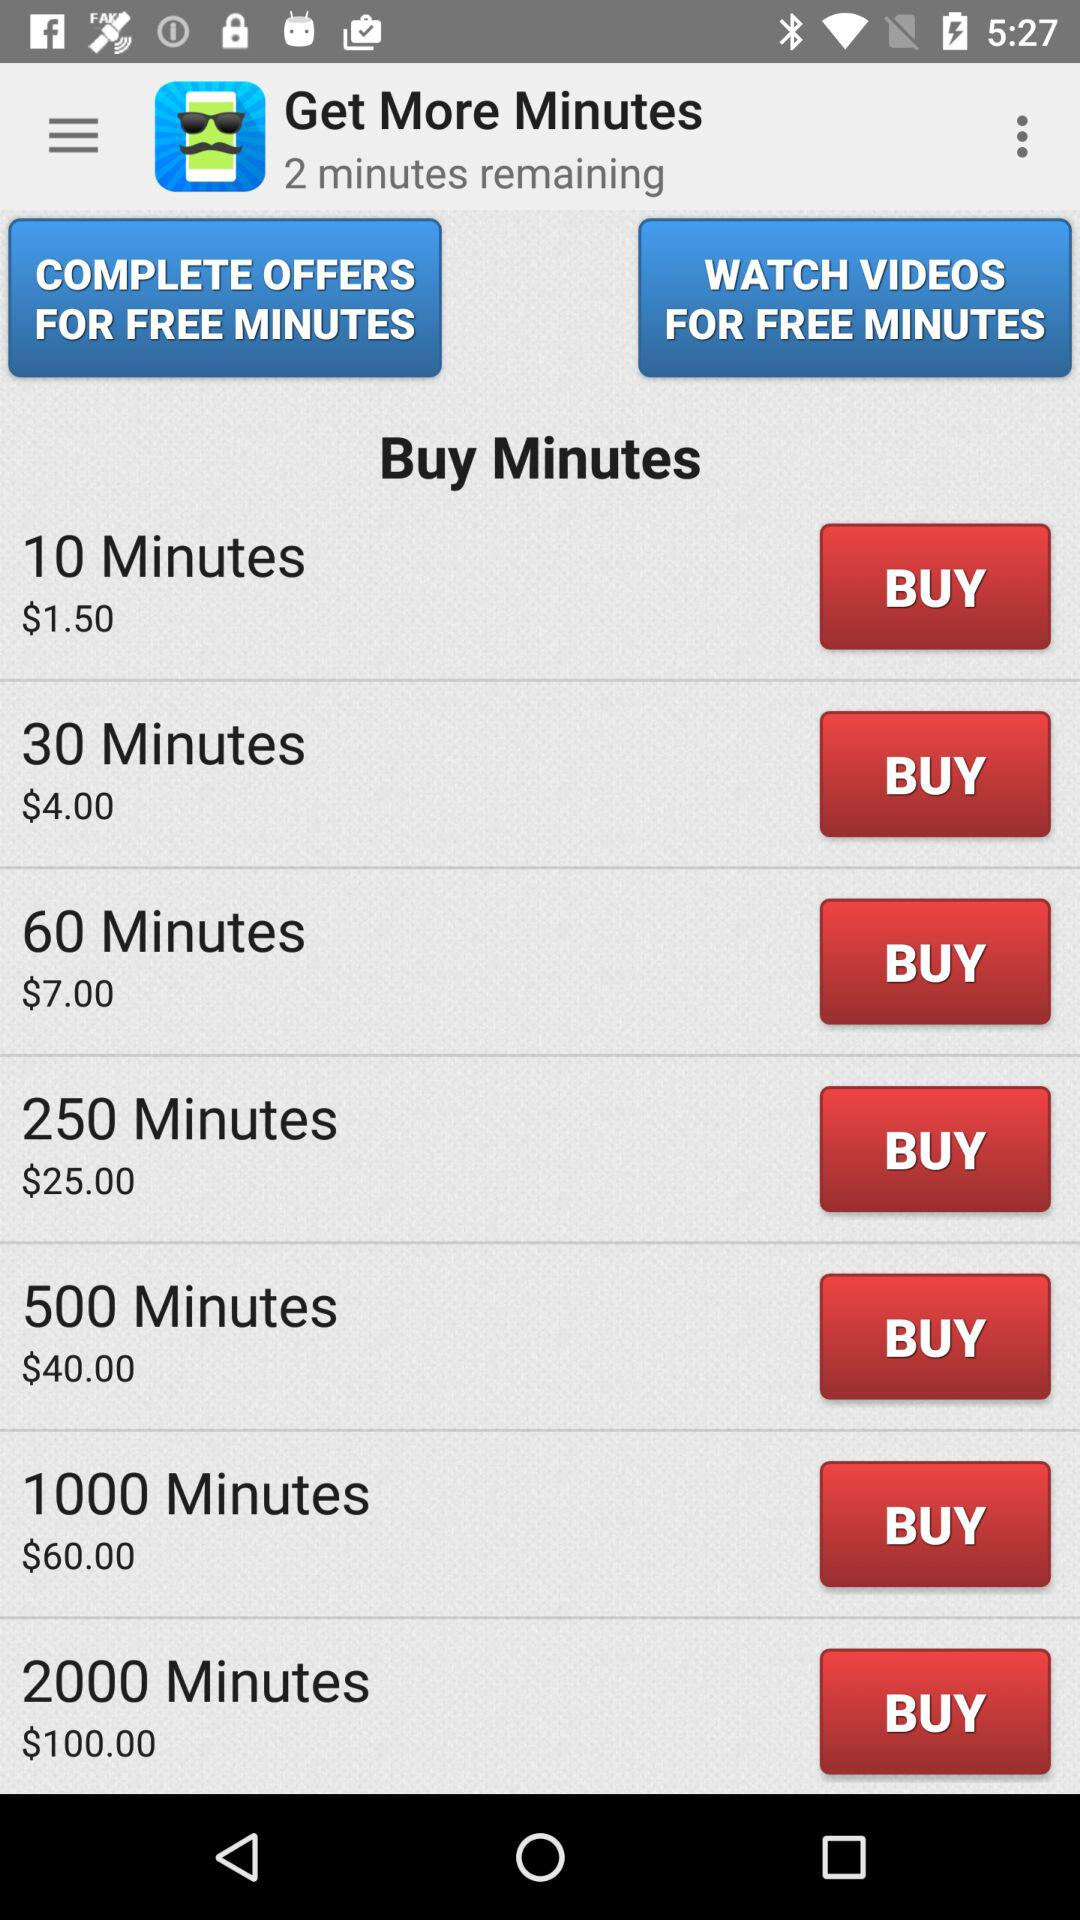What is the price of "2000 Minutes"? The price of "2000 Minutes" is $100.00. 